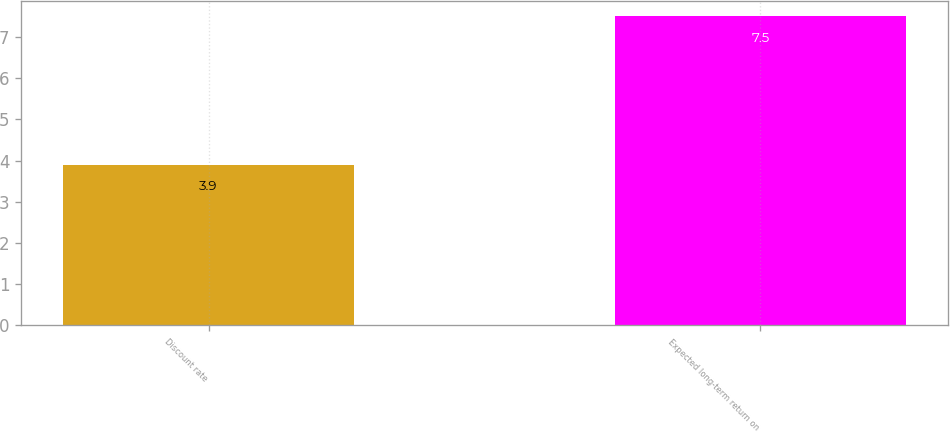Convert chart. <chart><loc_0><loc_0><loc_500><loc_500><bar_chart><fcel>Discount rate<fcel>Expected long-term return on<nl><fcel>3.9<fcel>7.5<nl></chart> 